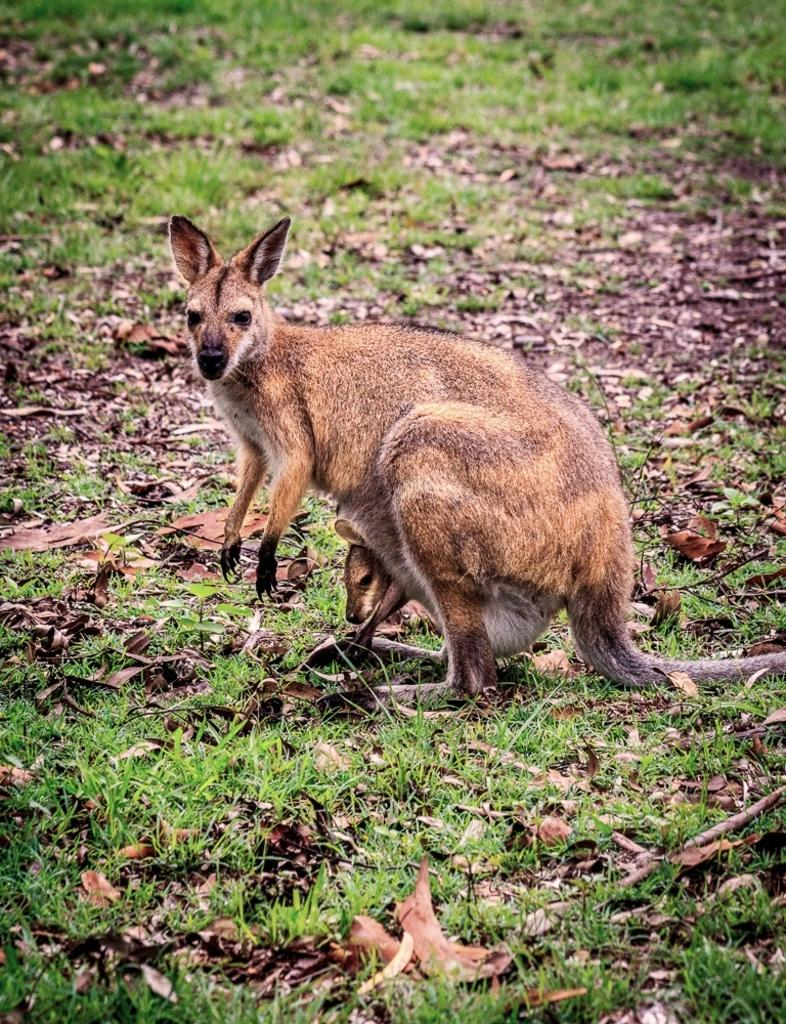What animal is the main subject of the picture? There is a kangaroo in the picture. Can you describe the kangaroo's offspring? There is a baby kangaroo in the pouch of the kangaroo. What type of vegetation can be seen in the picture? Leaves and grass are visible in the picture. What else can be seen on the ground in the image? There are other things visible on the ground. What type of rhythm is the kangaroo following in the image? There is no indication of a rhythm or any movement in the image; the kangaroo is stationary. How many ducks are visible in the image? There are no ducks present in the image. 